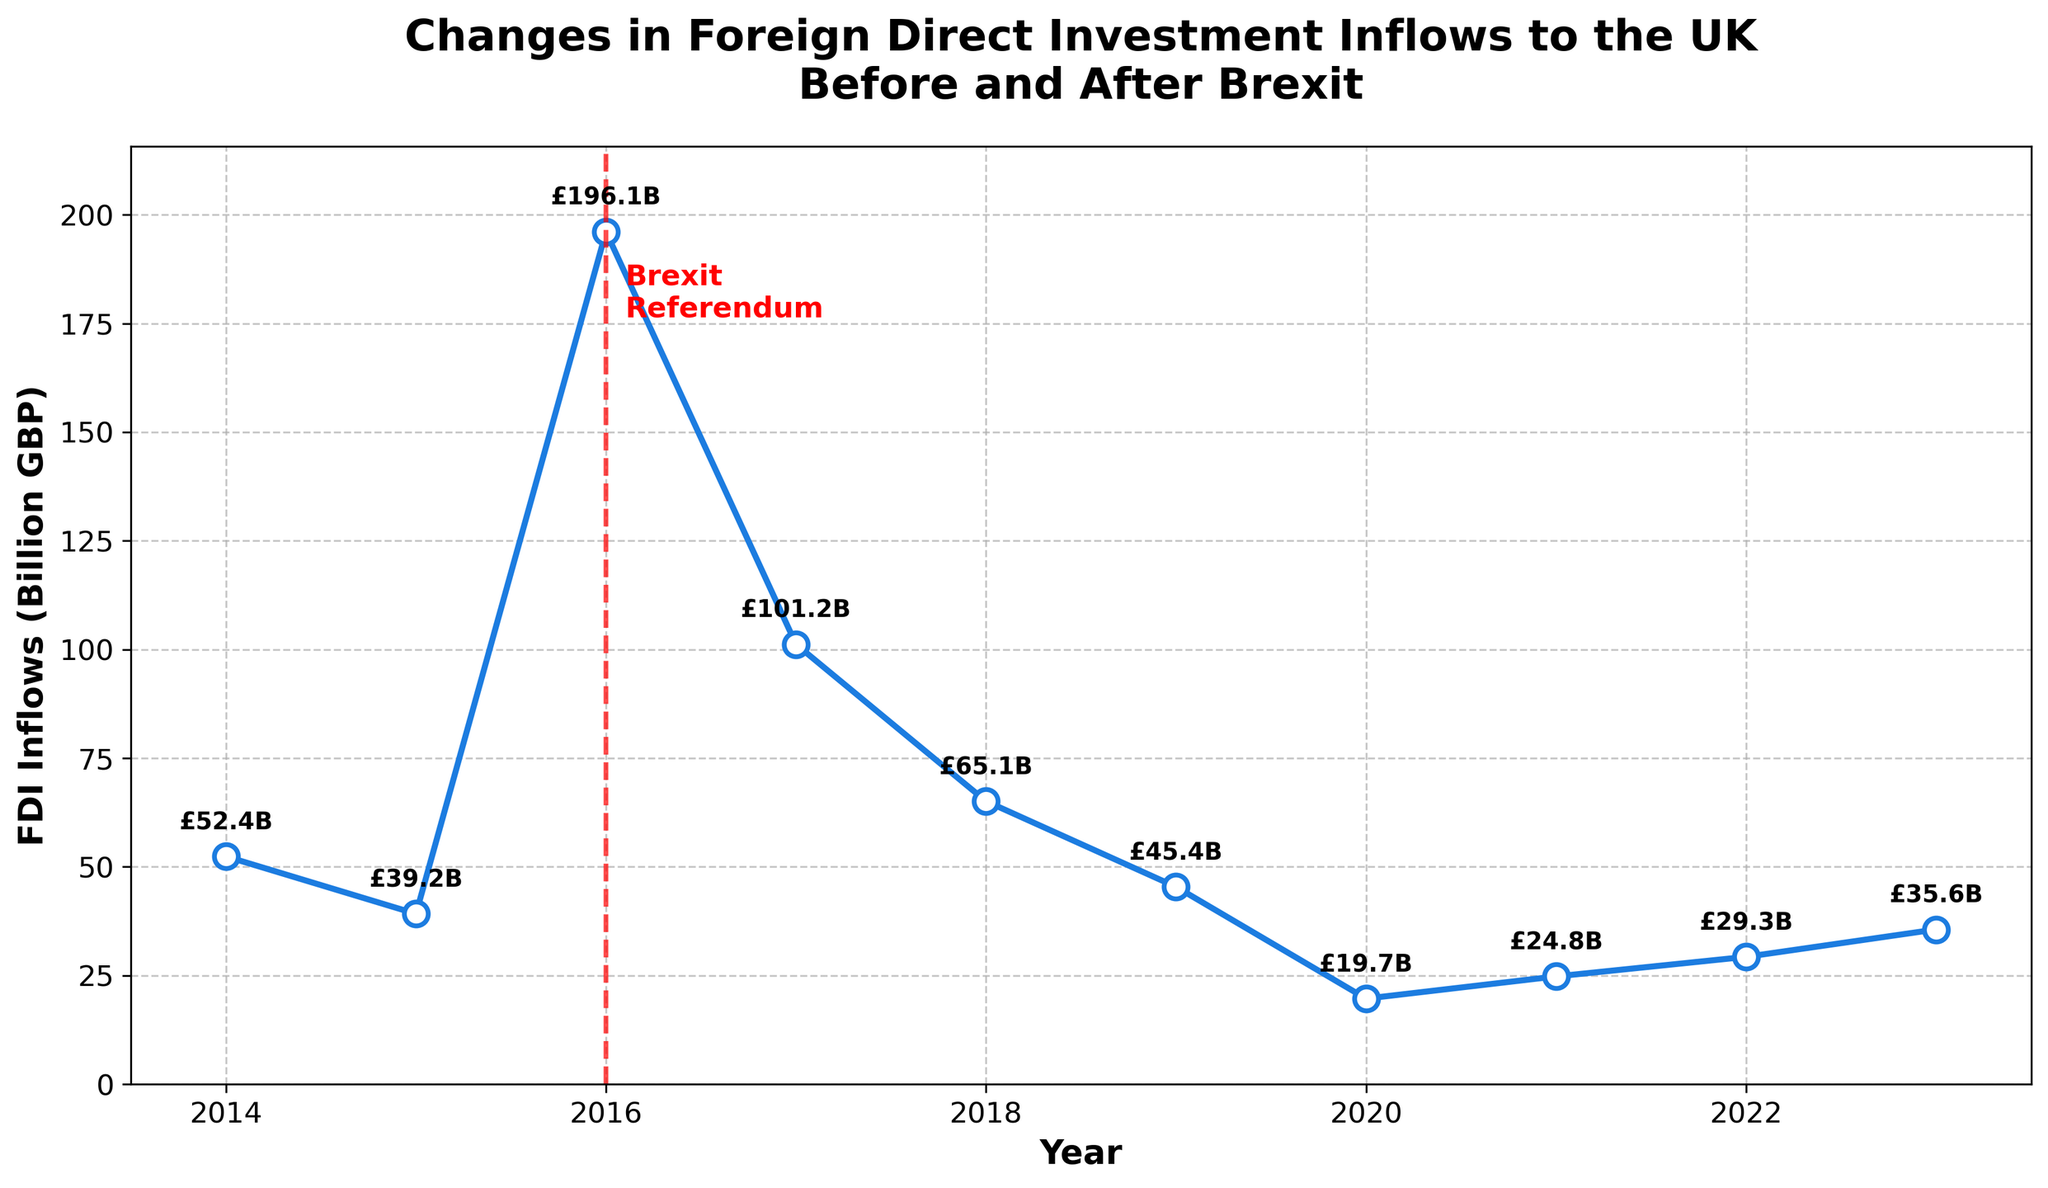What's the overall trend in FDI inflows to the UK before and after the Brexit referendum? By looking at the line chart, before the Brexit referendum in 2016, there is a significant spike in 2016 followed by a decline. After the referendum, there is a steady decrease with minor fluctuations. The overall trend is a decrease after the initial spike around 2016.
Answer: Decrease Which year had the highest FDI inflow and by how much? The highest FDI inflow occurred in 2016, as indicated by the peak of the line chart. The value for that year is marked as £196.1B on the chart.
Answer: 2016, £196.1B What is the difference in FDI inflows between 2016 and 2020? To find the difference, subtract the FDI inflow of 2020 from that of 2016: £196.1B - £19.7B.
Answer: £176.4B What is the average FDI inflow from 2017 to 2023? Sum the FDI inflows from 2017 to 2023 and divide by the number of years: (101.2 + 65.1 + 45.4 + 19.7 + 24.8 + 29.3 + 35.6) / 7 ≈ 46.44
Answer: £46.44B How did FDI inflows change immediately after the Brexit referendum (from 2016 to 2017)? Compare the FDI inflow values for 2016 and 2017. The value dropped from £196.1B in 2016 to £101.2B in 2017.
Answer: Decreased Which year experienced the lowest FDI inflow? The line chart shows the lowest FDI inflow occurring in 2020, marked as £19.7B.
Answer: 2020 How do the FDI inflows in 2019 compare to those in 2015? Compare the FDI inflow values for 2019 and 2015. In 2015, the inflow was £39.2B, while in 2019, it was £45.4B. 2019 had higher inflows than 2015.
Answer: 2019 is higher If we look at the period after 2016, in which year did FDI inflows show the most significant increase compared to the previous year? Check between consecutive years after 2016 and note the changes. The value increases the most from 2020 (£19.7B) to 2021 (£24.8B), an increase of £5.1B.
Answer: 2021 What visual element marks the Brexit referendum on the chart? The Brexit referendum in 2016 is marked by a red vertical dashed line and the text label 'Brexit Referendum' near the top.
Answer: Red vertical dashed line Is there any year after 2016 where FDI inflows reached or exceeded the 2015 value? The FDI inflow in 2015 was £39.2B. Review the chart for years after 2016 and compare to see no year after 2016 reached or exceeded £39.2B.
Answer: No 